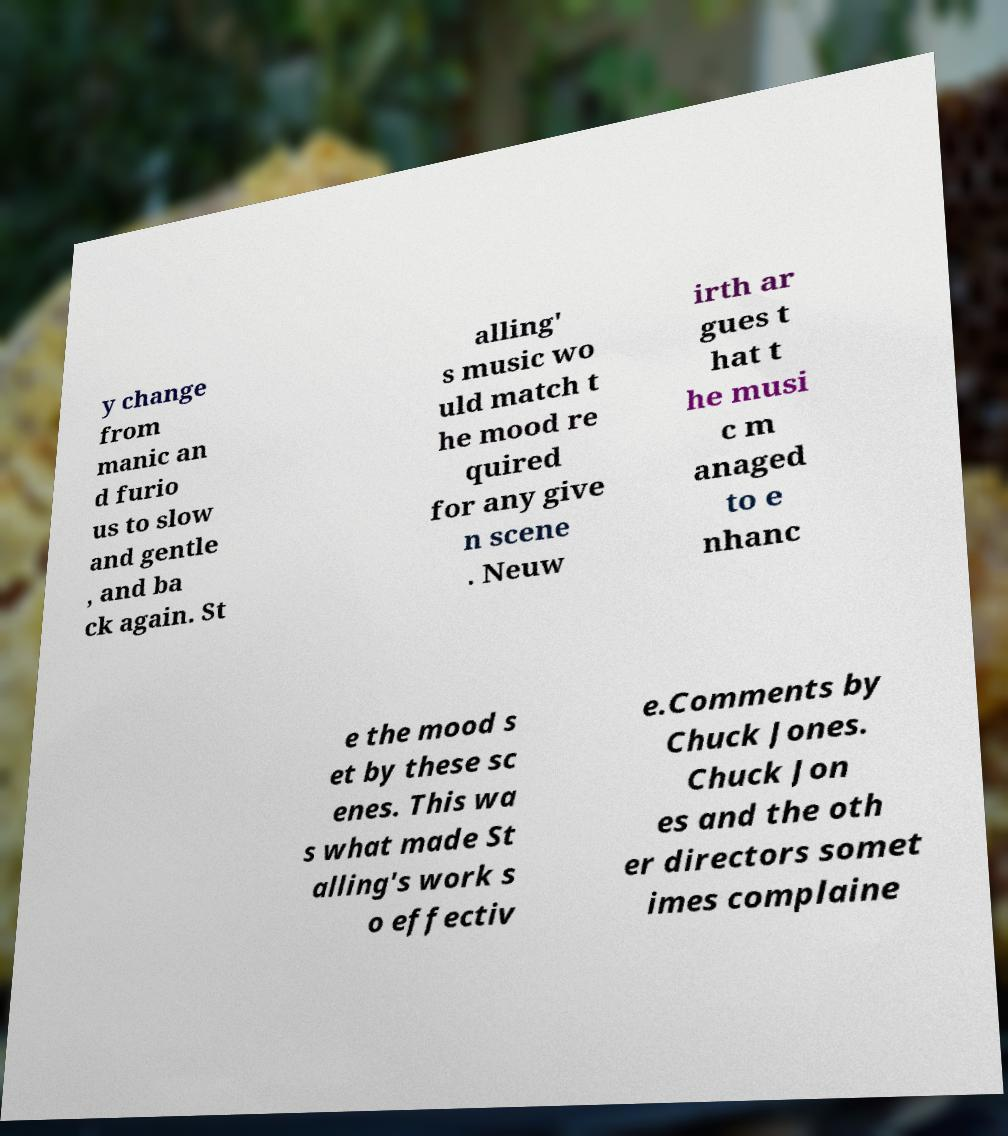Can you accurately transcribe the text from the provided image for me? y change from manic an d furio us to slow and gentle , and ba ck again. St alling' s music wo uld match t he mood re quired for any give n scene . Neuw irth ar gues t hat t he musi c m anaged to e nhanc e the mood s et by these sc enes. This wa s what made St alling's work s o effectiv e.Comments by Chuck Jones. Chuck Jon es and the oth er directors somet imes complaine 